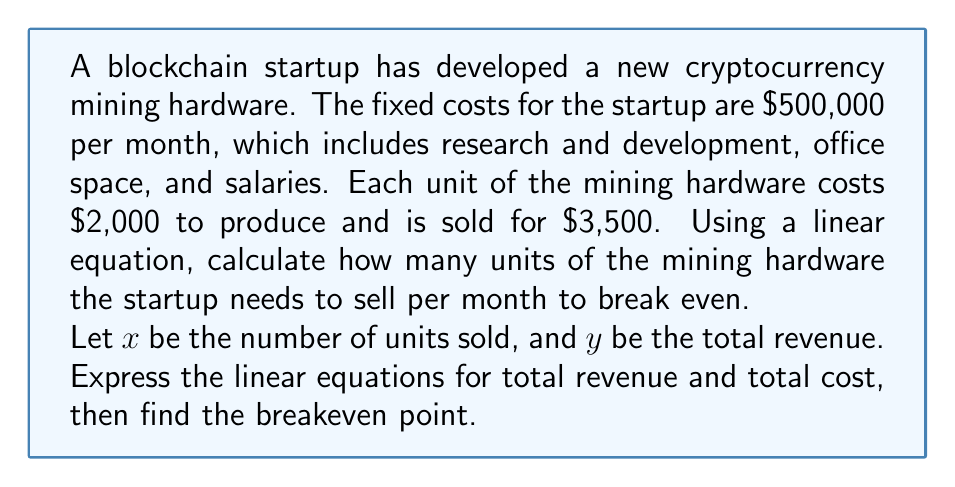Provide a solution to this math problem. To solve this problem, we need to set up two linear equations: one for total revenue and one for total cost. Then, we'll find the point where they intersect, which is the breakeven point.

1. Total Revenue Equation:
   Revenue per unit = $3,500
   $y = 3500x$

2. Total Cost Equation:
   Fixed costs = $500,000
   Variable cost per unit = $2,000
   $y = 500000 + 2000x$

3. At the breakeven point, Total Revenue = Total Cost:
   $3500x = 500000 + 2000x$

4. Solve for $x$:
   $3500x - 2000x = 500000$
   $1500x = 500000$
   $x = \frac{500000}{1500} = 333.33$

5. Since we can't sell a fraction of a unit, we round up to the nearest whole number:
   $x = 334$ units

To verify:
Total Revenue at 334 units: $3500 * 334 = 1,169,000$
Total Cost at 334 units: $500000 + (2000 * 334) = 1,168,000$

At 334 units, revenue slightly exceeds costs, confirming the breakeven point.
Answer: The blockchain startup needs to sell 334 units of the mining hardware per month to break even. 